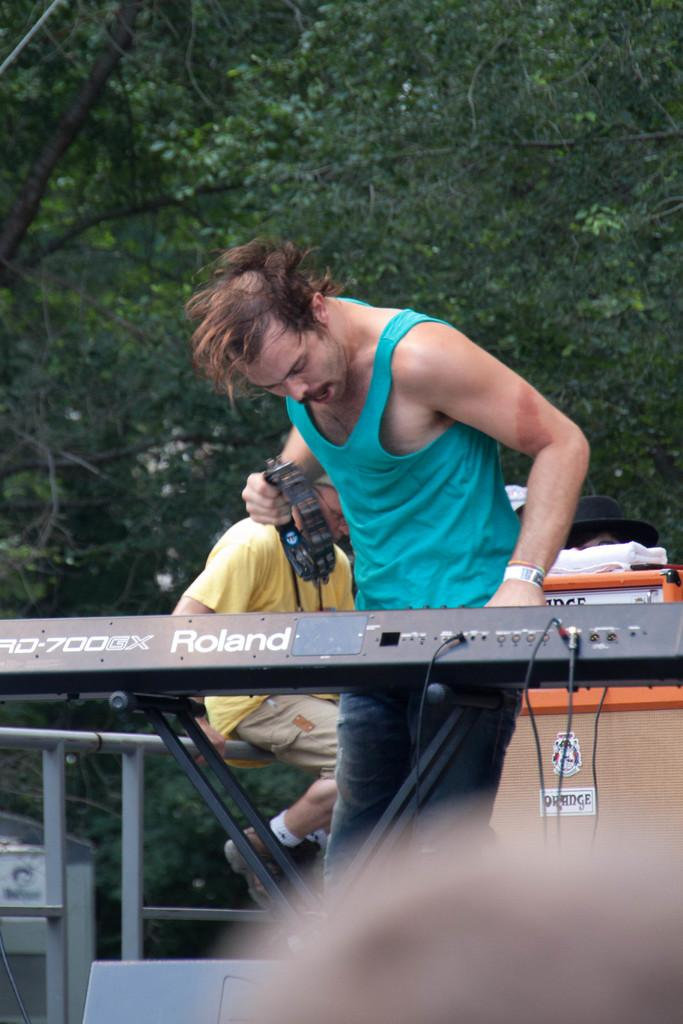How many people are in the image? There are people in the image, but the exact number is not specified. What is the man holding in his hand? The man is holding an object in his hand, but the specific object is not described. What is the man's posture in the image? The man is standing in the image. What are the rods used for in the image? The purpose of the rods in the image is not specified. What type of material is the cloth made of in the image? The material of the cloth in the image is not described. What is the cap used for in the image? The purpose of the cap in the image is not specified. What other objects are present in the image? There are other objects in the image, but their specific nature is not described. What can be seen in the background of the image? There are trees in the background of the image. Can you tell me how many robins are perched on the man's shoulder in the image? There are no robins present in the image. 